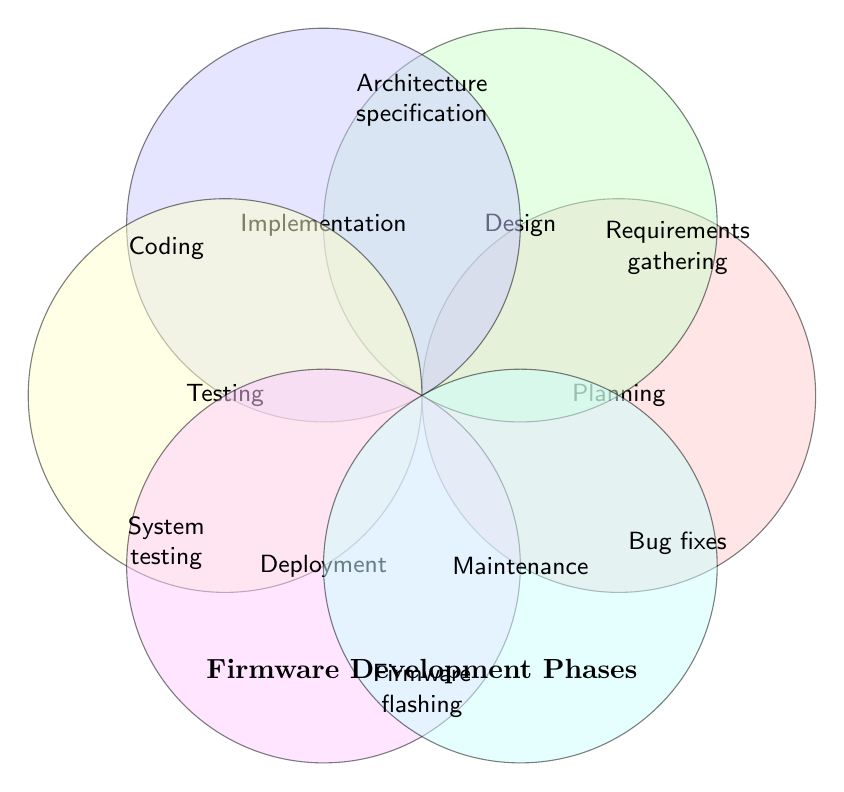what are the phases listed in the figure? The figure shows six phases, each indicated by a circle with a name inside. The phases are Planning, Design, Implementation, Testing, Deployment, and Maintenance.
Answer: Planning, Design, Implementation, Testing, Deployment, Maintenance Which phase includes requirements gathering? The figure shows the task "Requirements gathering" inside the circle labeled "Planning."
Answer: Planning Which tasks are associated with the Design phase? The circle labeled "Design" lists two tasks: "Architecture specification" and "Interface definition."
Answer: Architecture specification, Interface definition What is the phase for coding? The figure has "Coding" listed inside the circle labeled "Implementation."
Answer: Implementation How many tasks are listed for the Testing phase? The circle labeled "Testing" contains two tasks: "Integration testing" and "System testing."
Answer: 2 Which phase tasks involve tests? The figure shows that the Testing phase includes "Integration testing" and "System testing."
Answer: Testing Which phases have tasks related to system behavior? Deployment includes "Firmware flashing" and "Hardware compatibility check," and Maintenance includes "Bug fixes" and "Performance optimization."
Answer: Deployment, Maintenance Compare the number of tasks in Planning and Deployment phases. Planning has two tasks: "Requirements gathering" and "Resource allocation." Deployment also has two tasks: "Firmware flashing" and "Hardware compatibility check."
Answer: Both have 2 tasks Which phase follows Implementation? According to the standard development process order, Testing typically comes after Implementation.
Answer: Testing What's the relationship between Architecture specification and Interface definition? Both tasks fall under the Design phase, as indicated by their placement in the same circle.
Answer: Both are Design tasks 